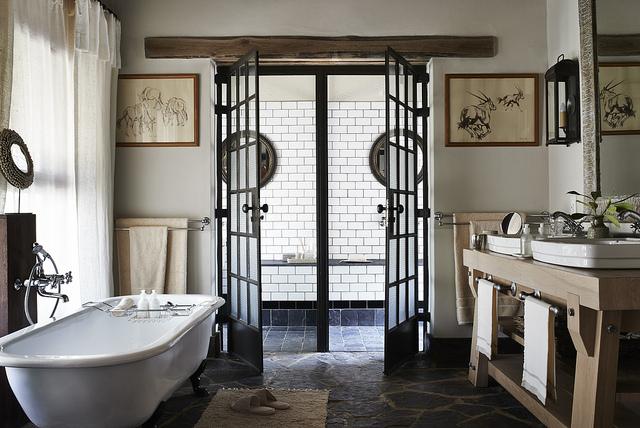What room is shown?
Quick response, please. Bathroom. Is the room lit by sunlight?
Quick response, please. Yes. Are the doors open?
Answer briefly. Yes. 